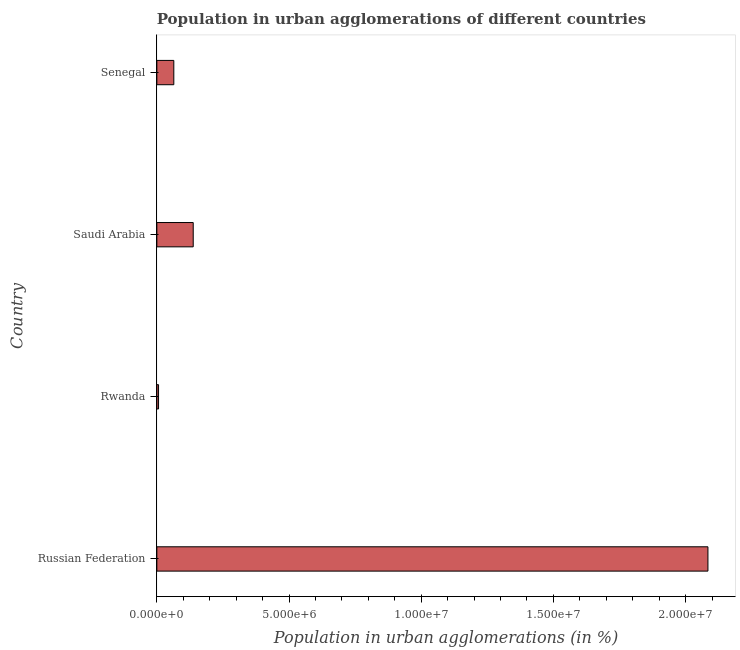Does the graph contain any zero values?
Offer a terse response. No. Does the graph contain grids?
Make the answer very short. No. What is the title of the graph?
Provide a short and direct response. Population in urban agglomerations of different countries. What is the label or title of the X-axis?
Your response must be concise. Population in urban agglomerations (in %). What is the population in urban agglomerations in Senegal?
Offer a terse response. 6.41e+05. Across all countries, what is the maximum population in urban agglomerations?
Offer a terse response. 2.08e+07. Across all countries, what is the minimum population in urban agglomerations?
Your response must be concise. 6.44e+04. In which country was the population in urban agglomerations maximum?
Provide a short and direct response. Russian Federation. In which country was the population in urban agglomerations minimum?
Your answer should be compact. Rwanda. What is the sum of the population in urban agglomerations?
Your answer should be very brief. 2.29e+07. What is the difference between the population in urban agglomerations in Russian Federation and Rwanda?
Keep it short and to the point. 2.08e+07. What is the average population in urban agglomerations per country?
Offer a very short reply. 5.73e+06. What is the median population in urban agglomerations?
Your answer should be very brief. 1.01e+06. What is the ratio of the population in urban agglomerations in Russian Federation to that in Senegal?
Your answer should be very brief. 32.49. Is the population in urban agglomerations in Rwanda less than that in Saudi Arabia?
Provide a short and direct response. Yes. Is the difference between the population in urban agglomerations in Rwanda and Senegal greater than the difference between any two countries?
Offer a terse response. No. What is the difference between the highest and the second highest population in urban agglomerations?
Provide a succinct answer. 1.95e+07. What is the difference between the highest and the lowest population in urban agglomerations?
Offer a terse response. 2.08e+07. In how many countries, is the population in urban agglomerations greater than the average population in urban agglomerations taken over all countries?
Offer a very short reply. 1. How many bars are there?
Ensure brevity in your answer.  4. Are the values on the major ticks of X-axis written in scientific E-notation?
Give a very brief answer. Yes. What is the Population in urban agglomerations (in %) in Russian Federation?
Give a very brief answer. 2.08e+07. What is the Population in urban agglomerations (in %) of Rwanda?
Offer a terse response. 6.44e+04. What is the Population in urban agglomerations (in %) in Saudi Arabia?
Provide a short and direct response. 1.38e+06. What is the Population in urban agglomerations (in %) in Senegal?
Offer a terse response. 6.41e+05. What is the difference between the Population in urban agglomerations (in %) in Russian Federation and Rwanda?
Your response must be concise. 2.08e+07. What is the difference between the Population in urban agglomerations (in %) in Russian Federation and Saudi Arabia?
Your response must be concise. 1.95e+07. What is the difference between the Population in urban agglomerations (in %) in Russian Federation and Senegal?
Provide a succinct answer. 2.02e+07. What is the difference between the Population in urban agglomerations (in %) in Rwanda and Saudi Arabia?
Your response must be concise. -1.31e+06. What is the difference between the Population in urban agglomerations (in %) in Rwanda and Senegal?
Offer a very short reply. -5.77e+05. What is the difference between the Population in urban agglomerations (in %) in Saudi Arabia and Senegal?
Provide a short and direct response. 7.34e+05. What is the ratio of the Population in urban agglomerations (in %) in Russian Federation to that in Rwanda?
Your answer should be compact. 323.9. What is the ratio of the Population in urban agglomerations (in %) in Russian Federation to that in Saudi Arabia?
Your answer should be very brief. 15.15. What is the ratio of the Population in urban agglomerations (in %) in Russian Federation to that in Senegal?
Offer a very short reply. 32.49. What is the ratio of the Population in urban agglomerations (in %) in Rwanda to that in Saudi Arabia?
Provide a succinct answer. 0.05. What is the ratio of the Population in urban agglomerations (in %) in Rwanda to that in Senegal?
Your answer should be compact. 0.1. What is the ratio of the Population in urban agglomerations (in %) in Saudi Arabia to that in Senegal?
Keep it short and to the point. 2.14. 